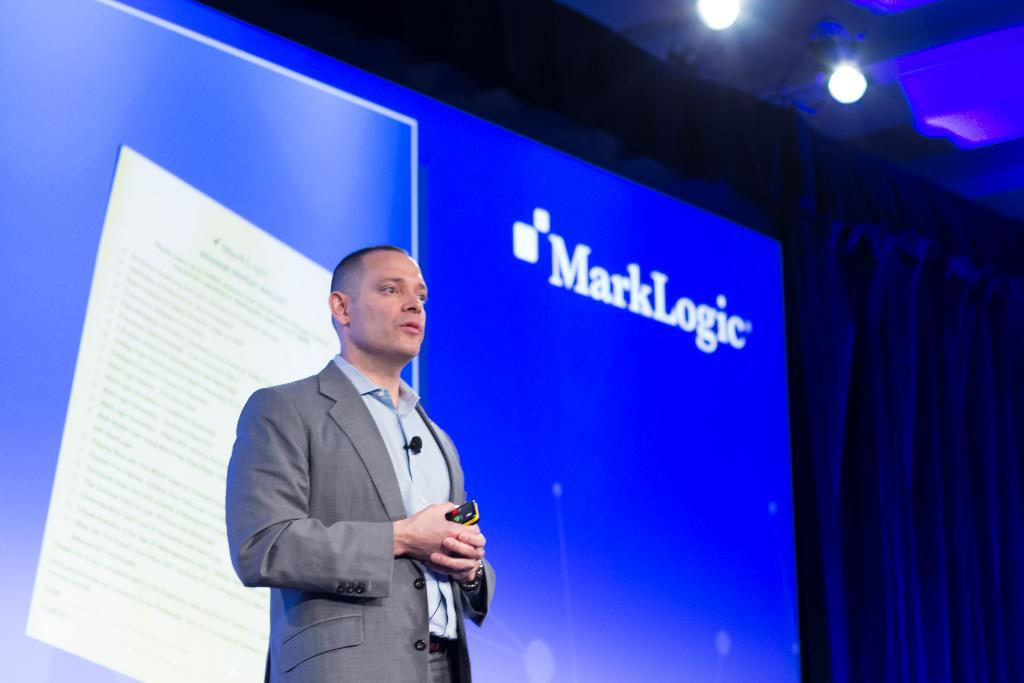Who is present in the image? There is a man in the image. What is the man wearing? The man is wearing a suit. What object is the man holding? The man is holding a remote. What can be seen in the background of the image? There is a screen in the background of the image. What type of lighting is visible in the image? There are lights visible at the top of the image. What type of window treatment is present in the image? There are curtains on the right side of the image. What list is the man regretting in the image? There is no list or indication of regret present in the image. 